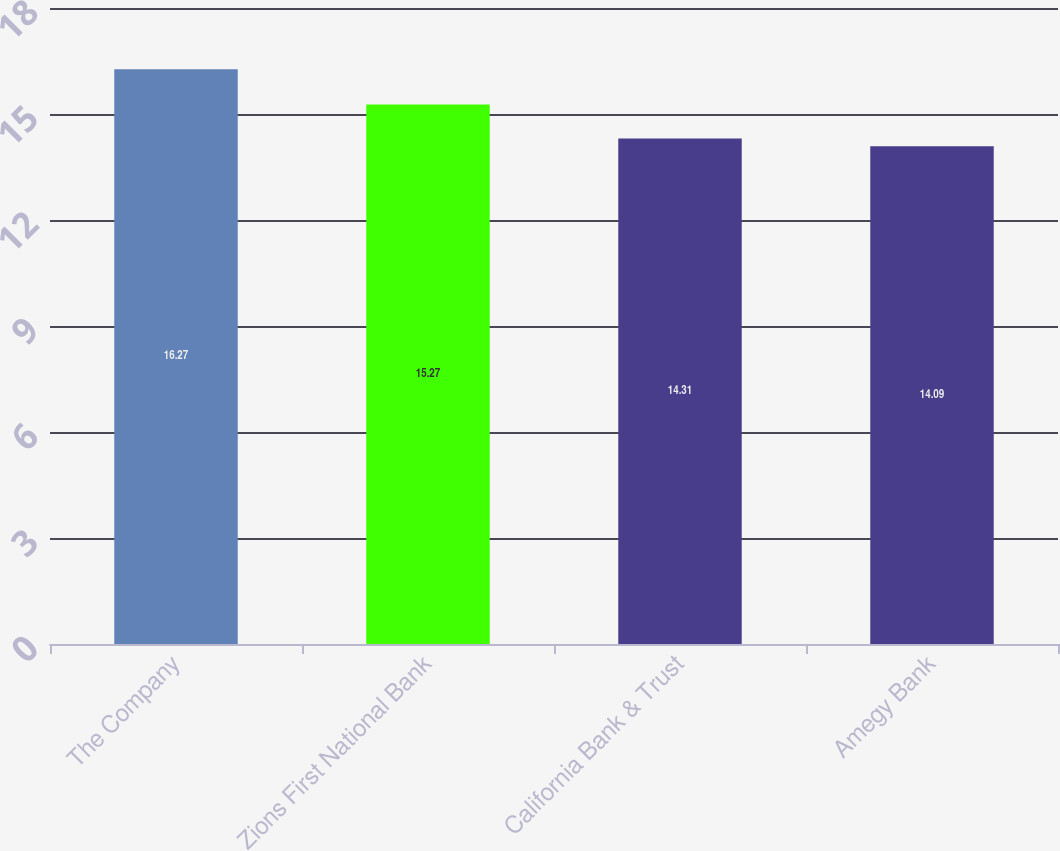<chart> <loc_0><loc_0><loc_500><loc_500><bar_chart><fcel>The Company<fcel>Zions First National Bank<fcel>California Bank & Trust<fcel>Amegy Bank<nl><fcel>16.27<fcel>15.27<fcel>14.31<fcel>14.09<nl></chart> 